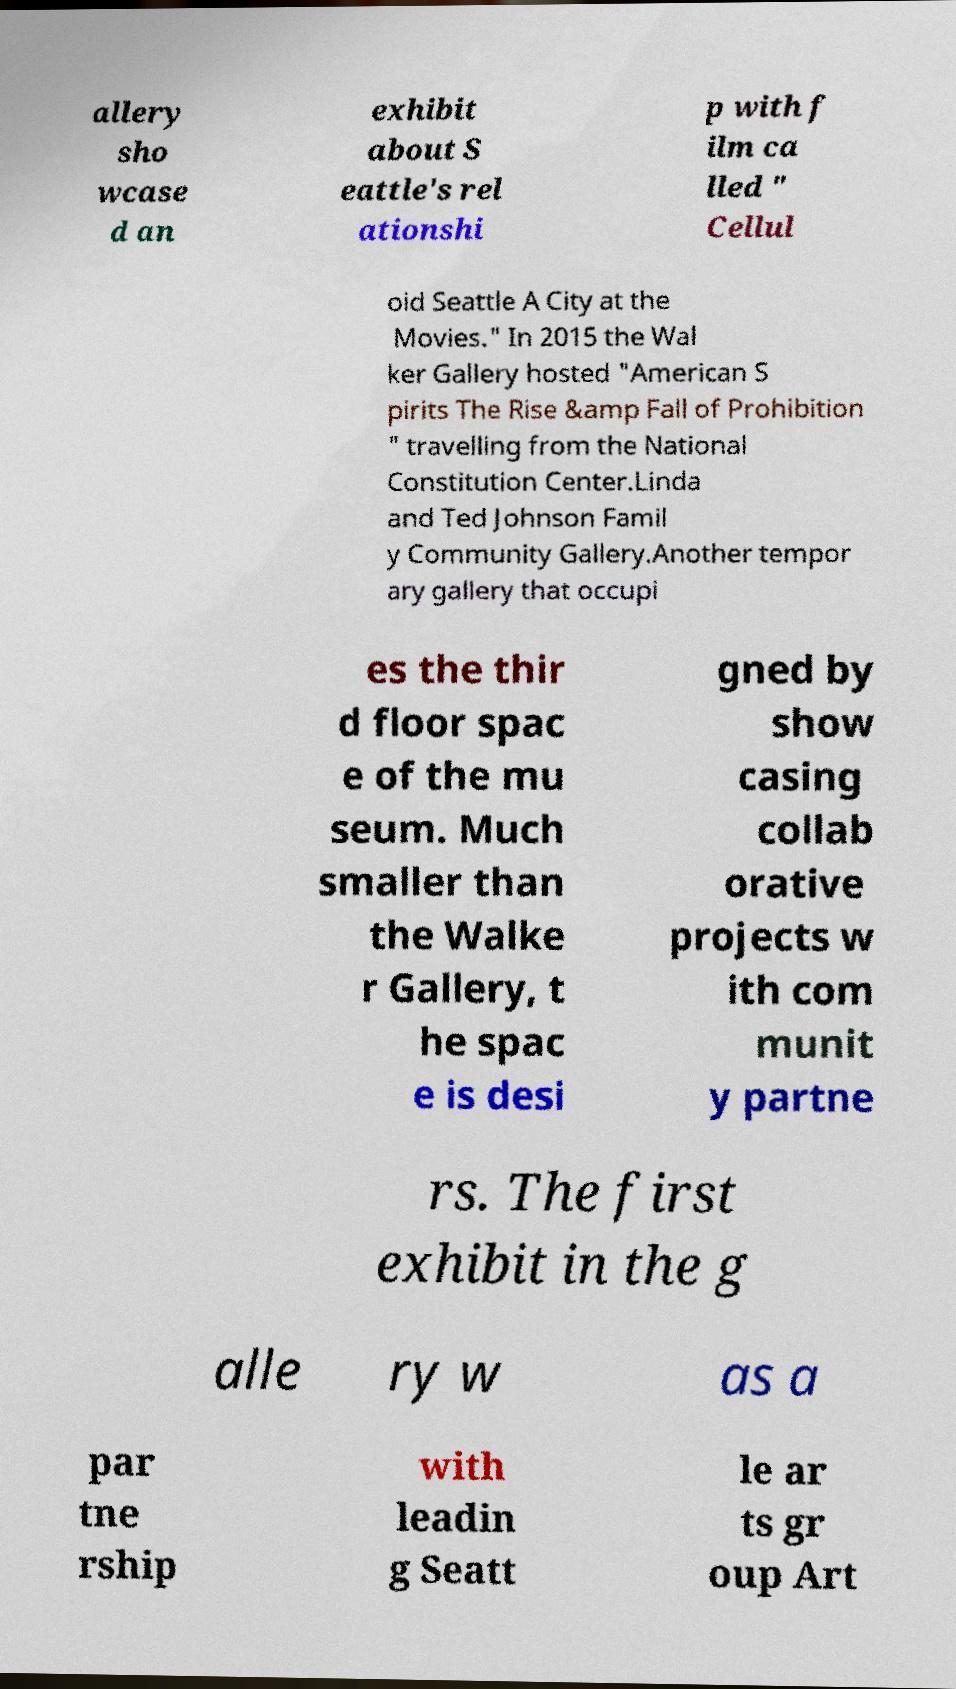Could you assist in decoding the text presented in this image and type it out clearly? allery sho wcase d an exhibit about S eattle's rel ationshi p with f ilm ca lled " Cellul oid Seattle A City at the Movies." In 2015 the Wal ker Gallery hosted "American S pirits The Rise &amp Fall of Prohibition " travelling from the National Constitution Center.Linda and Ted Johnson Famil y Community Gallery.Another tempor ary gallery that occupi es the thir d floor spac e of the mu seum. Much smaller than the Walke r Gallery, t he spac e is desi gned by show casing collab orative projects w ith com munit y partne rs. The first exhibit in the g alle ry w as a par tne rship with leadin g Seatt le ar ts gr oup Art 